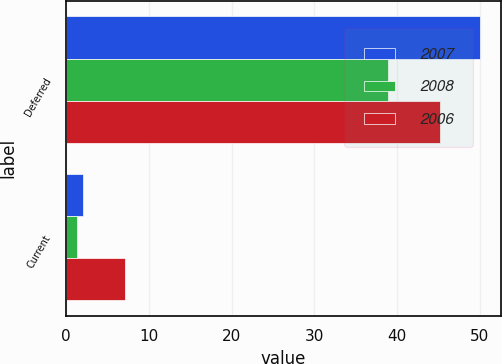Convert chart to OTSL. <chart><loc_0><loc_0><loc_500><loc_500><stacked_bar_chart><ecel><fcel>Deferred<fcel>Current<nl><fcel>2007<fcel>50<fcel>2<nl><fcel>2008<fcel>38.9<fcel>1.3<nl><fcel>2006<fcel>45.2<fcel>7.1<nl></chart> 